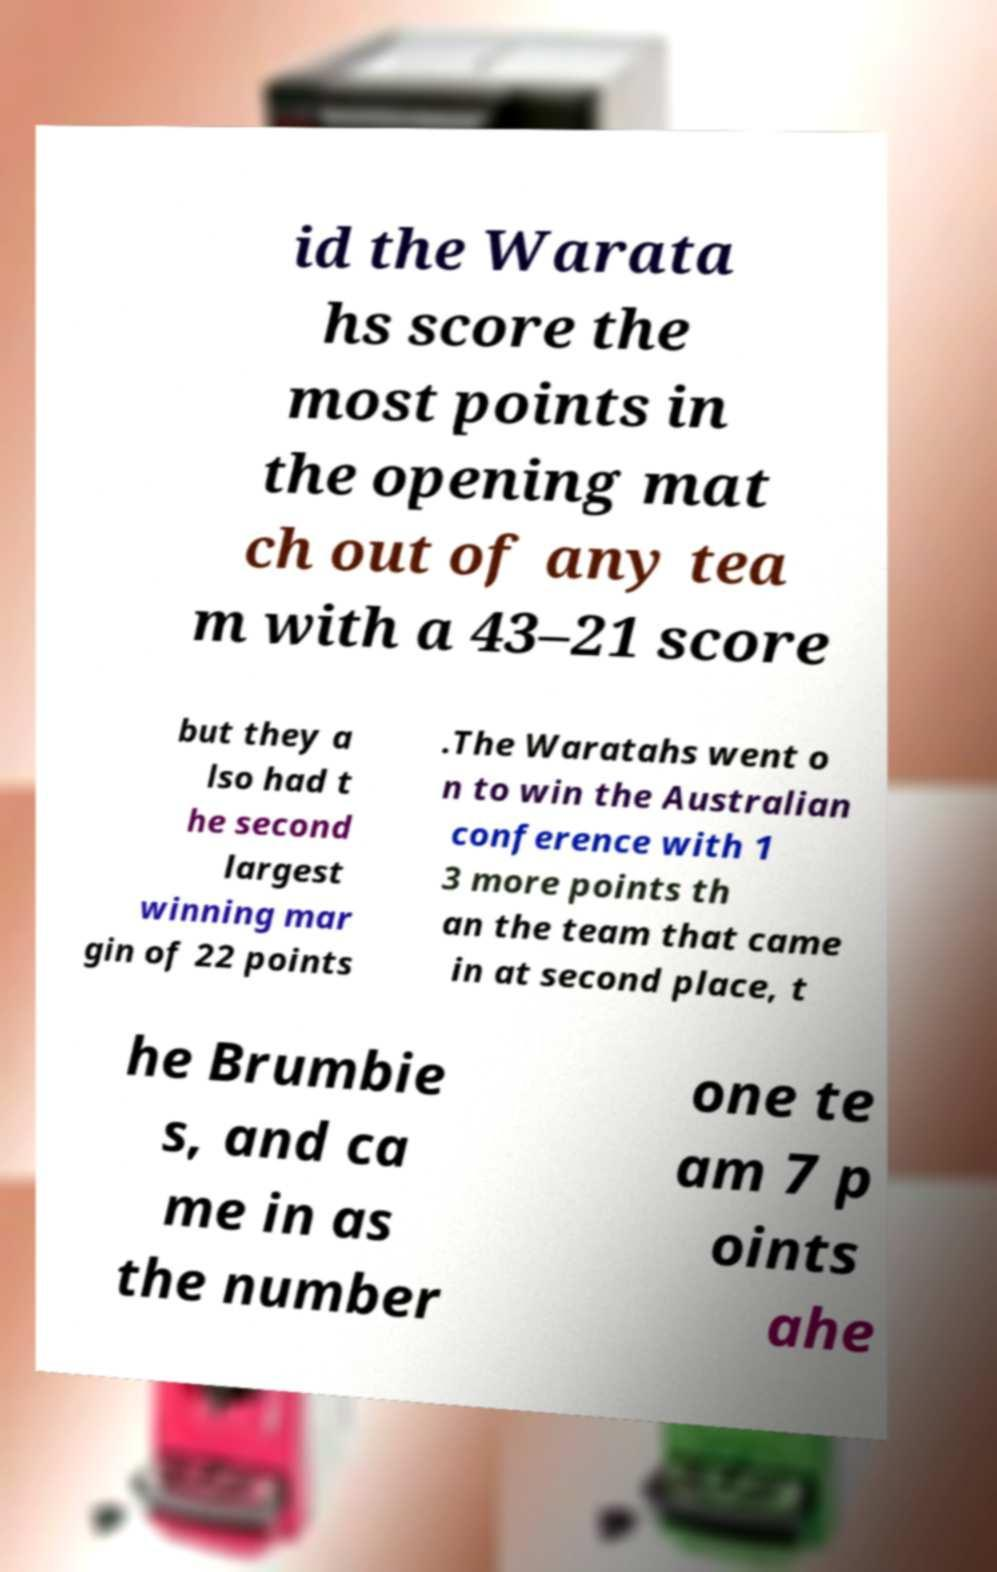Could you assist in decoding the text presented in this image and type it out clearly? id the Warata hs score the most points in the opening mat ch out of any tea m with a 43–21 score but they a lso had t he second largest winning mar gin of 22 points .The Waratahs went o n to win the Australian conference with 1 3 more points th an the team that came in at second place, t he Brumbie s, and ca me in as the number one te am 7 p oints ahe 